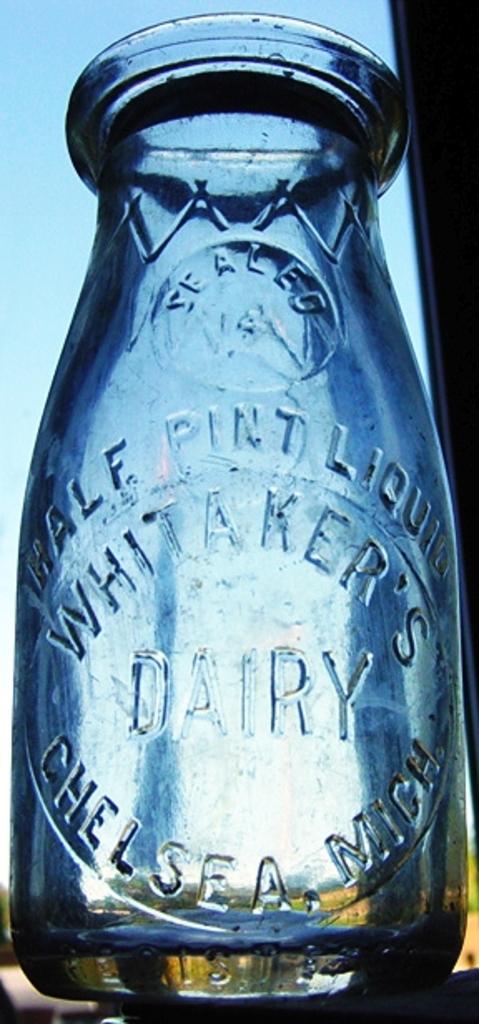What is usually put in this glass jar?
Provide a succinct answer. Dairy. What state is this from?
Keep it short and to the point. Michigan. 